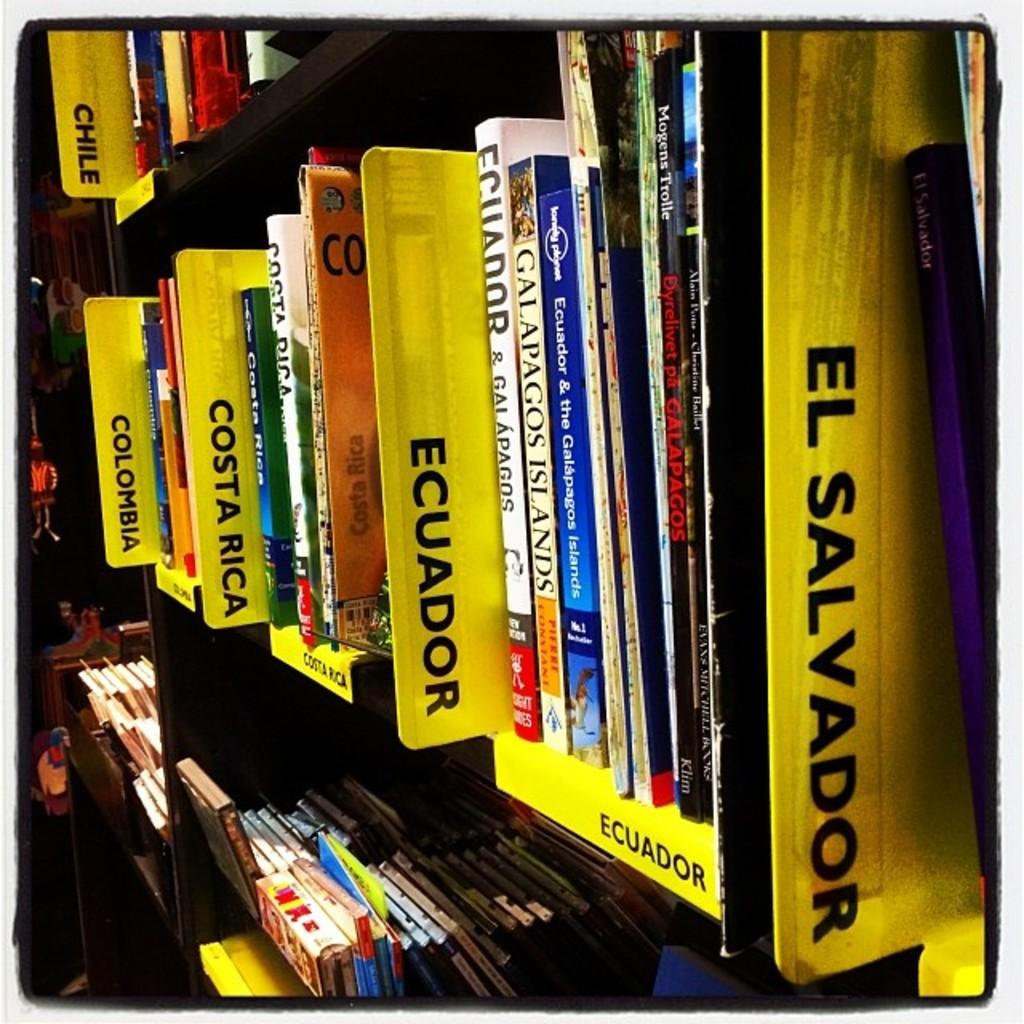<image>
Provide a brief description of the given image. A collection of books are organized by country. 